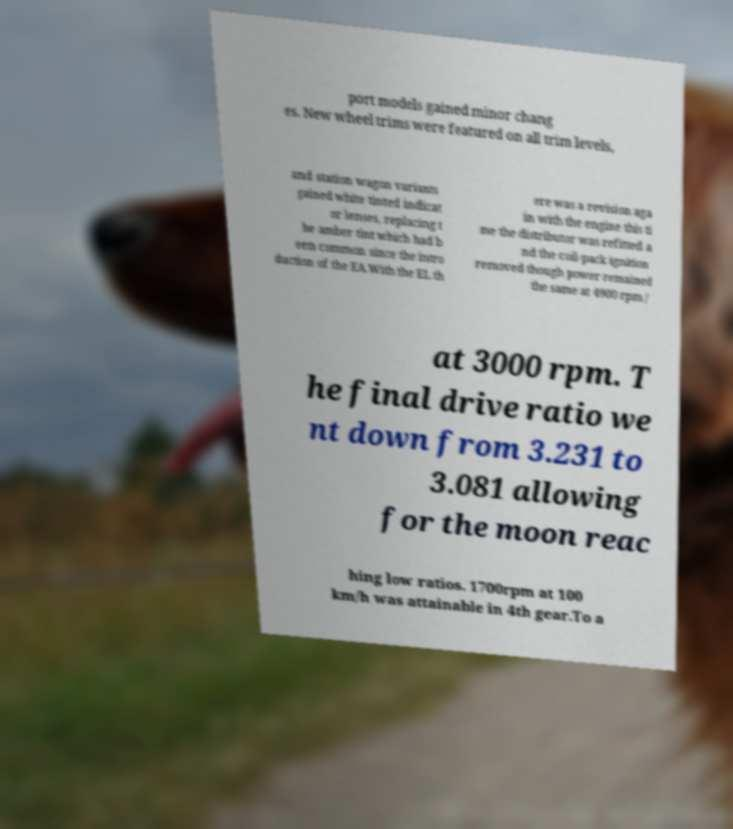I need the written content from this picture converted into text. Can you do that? port models gained minor chang es. New wheel trims were featured on all trim levels, and station wagon variants gained white tinted indicat or lenses, replacing t he amber tint which had b een common since the intro duction of the EA.With the EL th ere was a revision aga in with the engine this ti me the distributor was refitted a nd the coil-pack ignition removed though power remained the same at 4900 rpm / at 3000 rpm. T he final drive ratio we nt down from 3.231 to 3.081 allowing for the moon reac hing low ratios. 1700rpm at 100 km/h was attainable in 4th gear.To a 